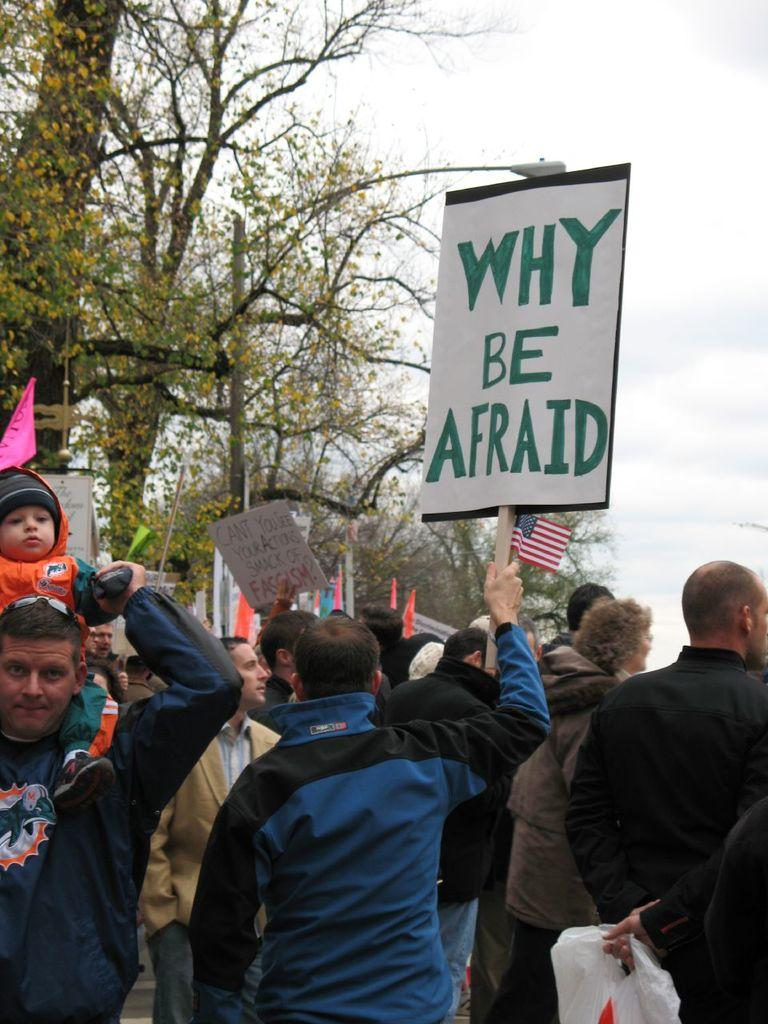Provide a one-sentence caption for the provided image. People are protesting and holding up a sign not be afraid. 